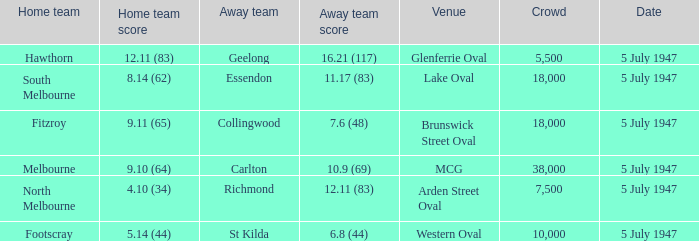Who was the away team when North Melbourne was the home team? Richmond. 